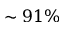Convert formula to latex. <formula><loc_0><loc_0><loc_500><loc_500>\sim 9 1 \%</formula> 